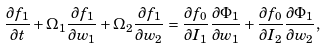Convert formula to latex. <formula><loc_0><loc_0><loc_500><loc_500>\frac { \partial f _ { 1 } } { \partial t } + \Omega _ { 1 } \frac { \partial f _ { 1 } } { \partial w _ { 1 } } + \Omega _ { 2 } \frac { \partial f _ { 1 } } { \partial w _ { 2 } } = \frac { \partial f _ { 0 } } { \partial I _ { 1 } } \frac { \partial \Phi _ { 1 } } { \partial w _ { 1 } } + \frac { \partial f _ { 0 } } { \partial I _ { 2 } } \frac { \partial \Phi _ { 1 } } { \partial w _ { 2 } } ,</formula> 